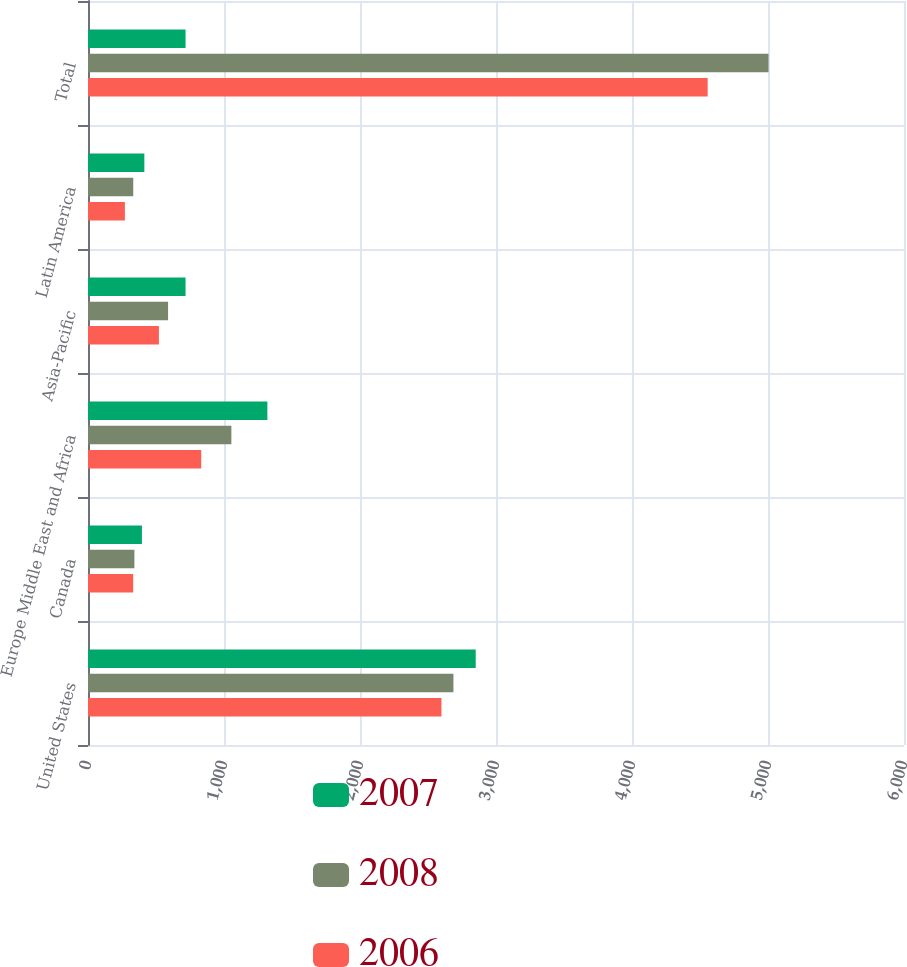Convert chart. <chart><loc_0><loc_0><loc_500><loc_500><stacked_bar_chart><ecel><fcel>United States<fcel>Canada<fcel>Europe Middle East and Africa<fcel>Asia-Pacific<fcel>Latin America<fcel>Total<nl><fcel>2007<fcel>2850.8<fcel>396.4<fcel>1319<fcel>717.2<fcel>414.4<fcel>717.2<nl><fcel>2008<fcel>2687<fcel>341.1<fcel>1054.2<fcel>588.8<fcel>332.8<fcel>5003.9<nl><fcel>2006<fcel>2599<fcel>332.1<fcel>832.6<fcel>521.4<fcel>271.3<fcel>4556.4<nl></chart> 